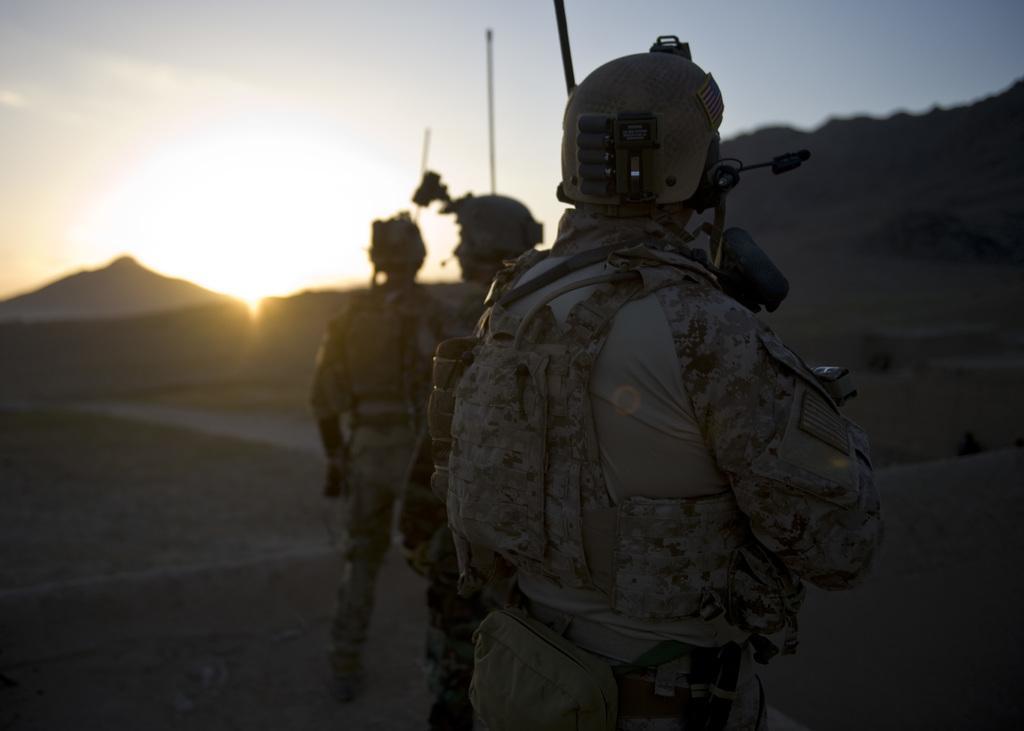How would you summarize this image in a sentence or two? In this image there are three people standing on the land. They are wearing helmets. Background there are hills. Top of the image there is sky having a son. 